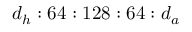<formula> <loc_0><loc_0><loc_500><loc_500>d _ { h } \colon 6 4 \colon 1 2 8 \colon 6 4 \colon d _ { a }</formula> 